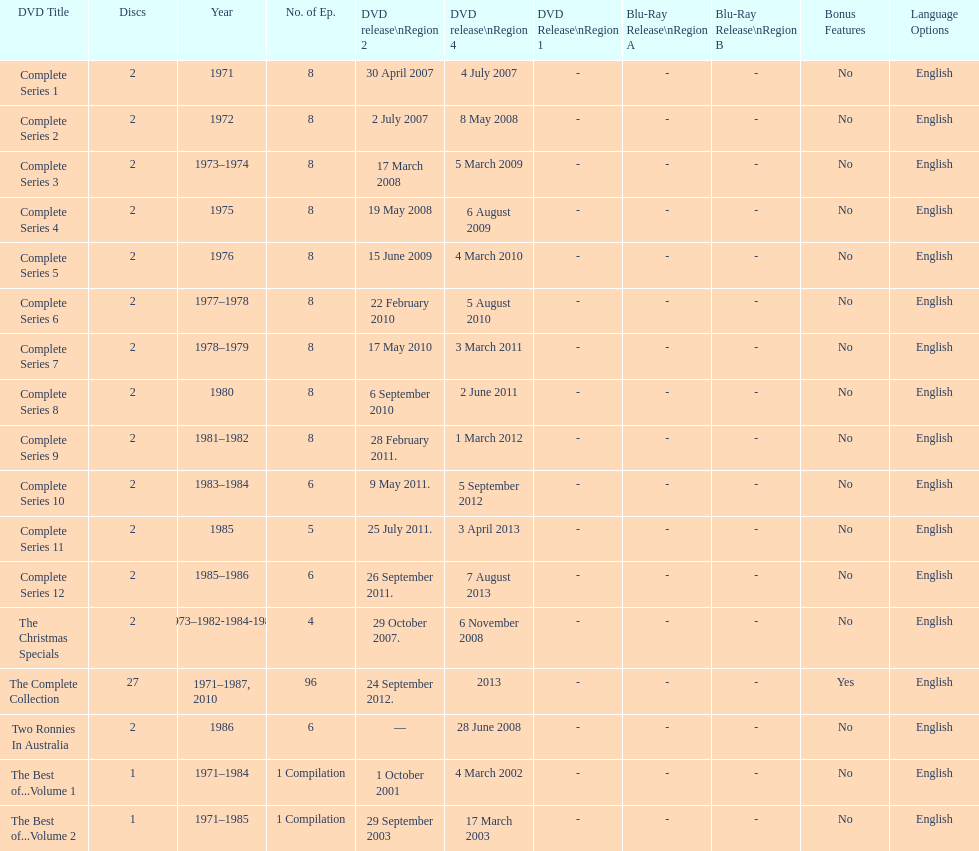Can it be confirmed that each season of "the two ronnies" television program contained more than 10 episodes? False. 